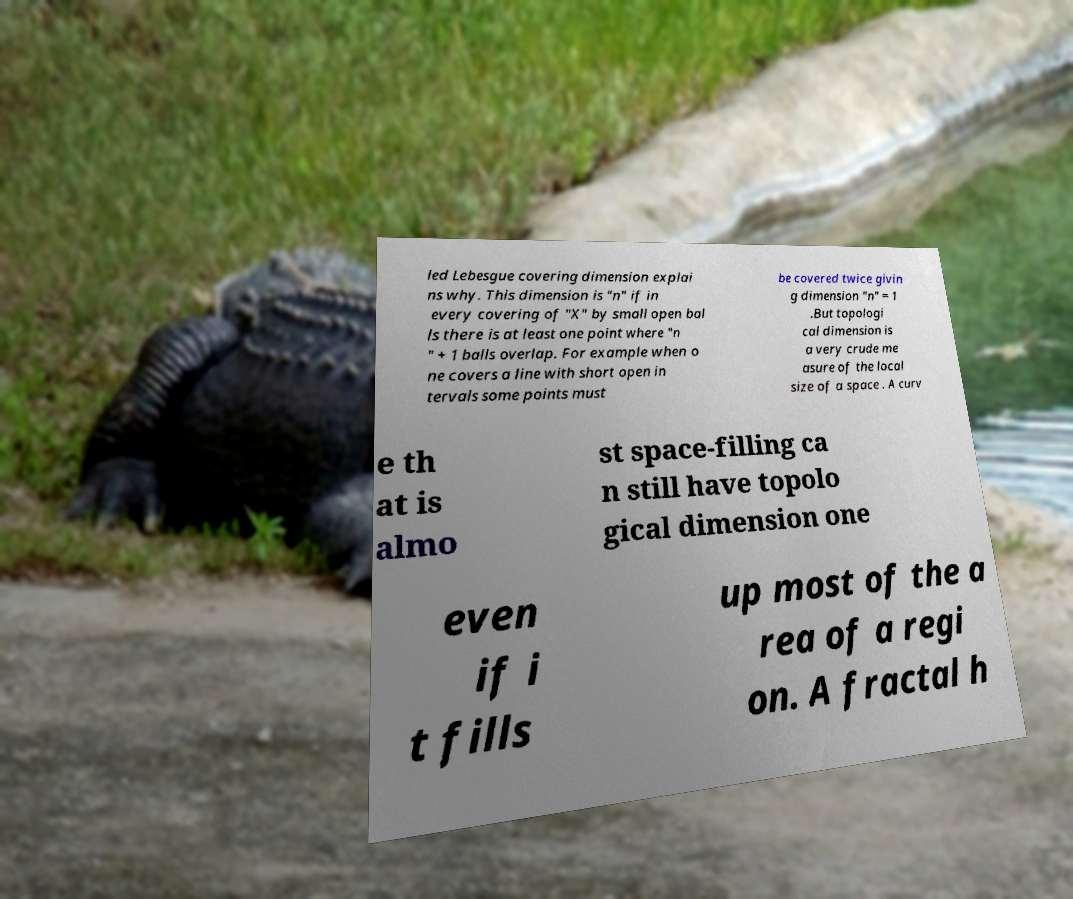There's text embedded in this image that I need extracted. Can you transcribe it verbatim? led Lebesgue covering dimension explai ns why. This dimension is "n" if in every covering of "X" by small open bal ls there is at least one point where "n " + 1 balls overlap. For example when o ne covers a line with short open in tervals some points must be covered twice givin g dimension "n" = 1 .But topologi cal dimension is a very crude me asure of the local size of a space . A curv e th at is almo st space-filling ca n still have topolo gical dimension one even if i t fills up most of the a rea of a regi on. A fractal h 